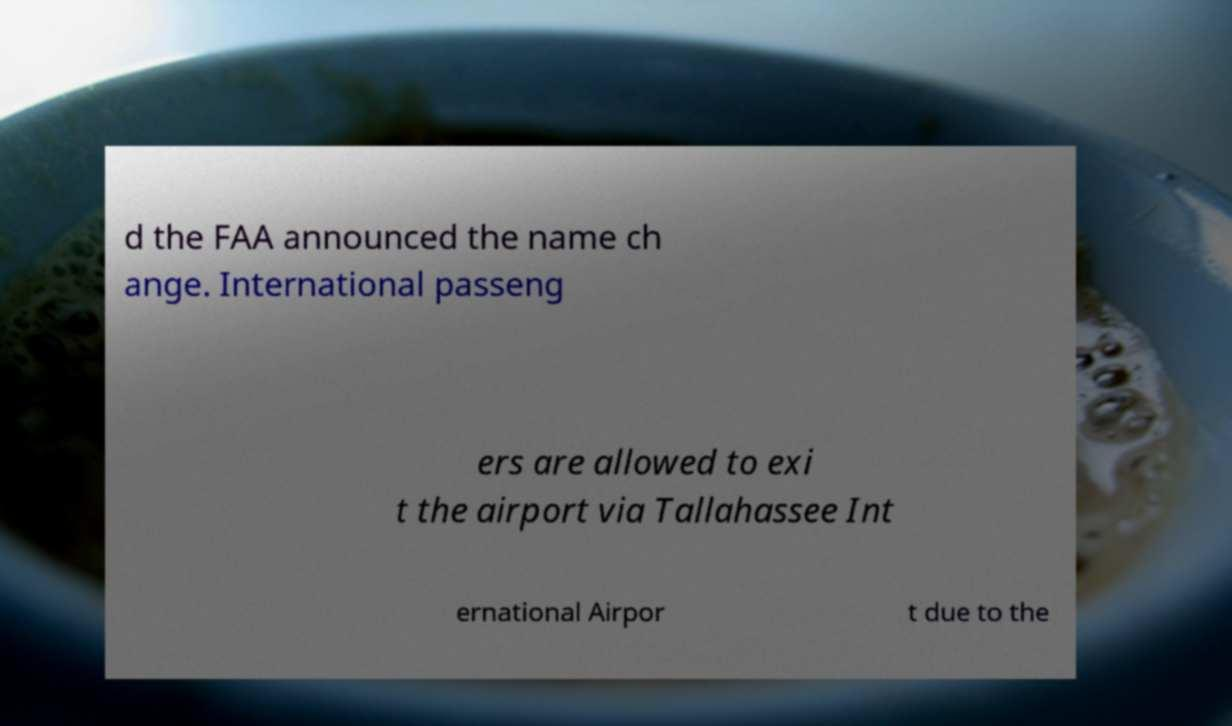I need the written content from this picture converted into text. Can you do that? d the FAA announced the name ch ange. International passeng ers are allowed to exi t the airport via Tallahassee Int ernational Airpor t due to the 